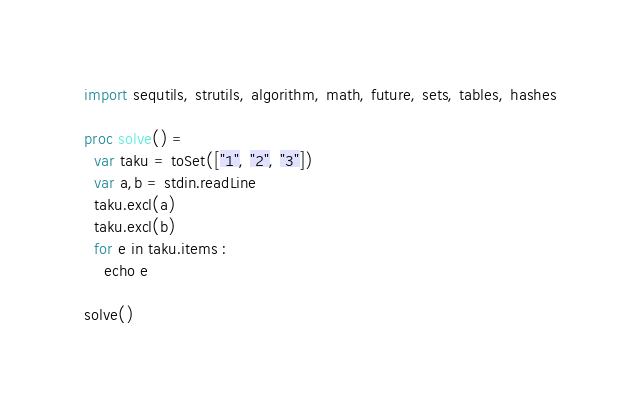<code> <loc_0><loc_0><loc_500><loc_500><_Nim_>import sequtils, strutils, algorithm, math, future, sets, tables, hashes

proc solve() =
  var taku = toSet(["1", "2", "3"])
  var a,b = stdin.readLine
  taku.excl(a)
  taku.excl(b)
  for e in taku.items : 
    echo e

solve()</code> 